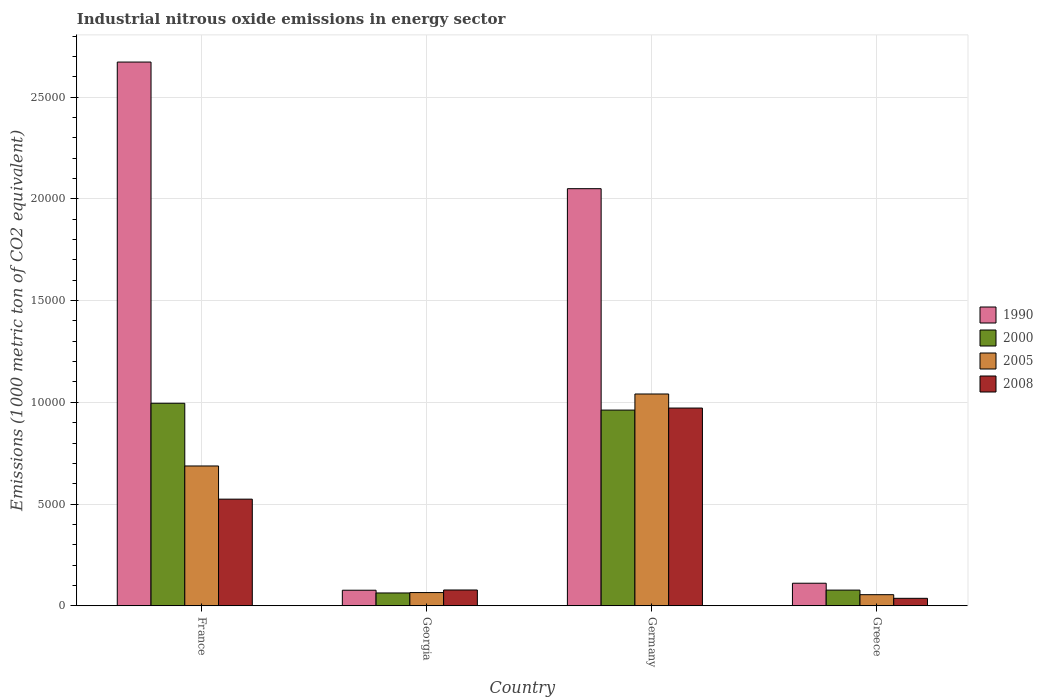How many different coloured bars are there?
Your answer should be compact. 4. Are the number of bars per tick equal to the number of legend labels?
Offer a very short reply. Yes. How many bars are there on the 1st tick from the left?
Make the answer very short. 4. How many bars are there on the 4th tick from the right?
Your answer should be very brief. 4. What is the amount of industrial nitrous oxide emitted in 1990 in France?
Your answer should be very brief. 2.67e+04. Across all countries, what is the maximum amount of industrial nitrous oxide emitted in 2005?
Your answer should be compact. 1.04e+04. Across all countries, what is the minimum amount of industrial nitrous oxide emitted in 2008?
Provide a short and direct response. 367.4. In which country was the amount of industrial nitrous oxide emitted in 2008 minimum?
Your response must be concise. Greece. What is the total amount of industrial nitrous oxide emitted in 2008 in the graph?
Offer a very short reply. 1.61e+04. What is the difference between the amount of industrial nitrous oxide emitted in 2008 in France and that in Georgia?
Provide a short and direct response. 4464.8. What is the difference between the amount of industrial nitrous oxide emitted in 1990 in Greece and the amount of industrial nitrous oxide emitted in 2005 in Georgia?
Give a very brief answer. 459. What is the average amount of industrial nitrous oxide emitted in 2005 per country?
Your answer should be very brief. 4619.1. What is the difference between the amount of industrial nitrous oxide emitted of/in 2000 and amount of industrial nitrous oxide emitted of/in 1990 in France?
Provide a short and direct response. -1.68e+04. What is the ratio of the amount of industrial nitrous oxide emitted in 2005 in France to that in Georgia?
Your response must be concise. 10.57. Is the amount of industrial nitrous oxide emitted in 2005 in Germany less than that in Greece?
Offer a very short reply. No. What is the difference between the highest and the second highest amount of industrial nitrous oxide emitted in 2000?
Offer a very short reply. 335.9. What is the difference between the highest and the lowest amount of industrial nitrous oxide emitted in 2005?
Ensure brevity in your answer.  9863.1. In how many countries, is the amount of industrial nitrous oxide emitted in 1990 greater than the average amount of industrial nitrous oxide emitted in 1990 taken over all countries?
Provide a short and direct response. 2. Is it the case that in every country, the sum of the amount of industrial nitrous oxide emitted in 2000 and amount of industrial nitrous oxide emitted in 2008 is greater than the sum of amount of industrial nitrous oxide emitted in 2005 and amount of industrial nitrous oxide emitted in 1990?
Your response must be concise. No. What does the 1st bar from the left in France represents?
Provide a succinct answer. 1990. What does the 1st bar from the right in Greece represents?
Your response must be concise. 2008. What is the difference between two consecutive major ticks on the Y-axis?
Offer a terse response. 5000. Are the values on the major ticks of Y-axis written in scientific E-notation?
Offer a terse response. No. Where does the legend appear in the graph?
Your answer should be compact. Center right. How many legend labels are there?
Make the answer very short. 4. How are the legend labels stacked?
Provide a short and direct response. Vertical. What is the title of the graph?
Offer a terse response. Industrial nitrous oxide emissions in energy sector. What is the label or title of the X-axis?
Ensure brevity in your answer.  Country. What is the label or title of the Y-axis?
Your response must be concise. Emissions (1000 metric ton of CO2 equivalent). What is the Emissions (1000 metric ton of CO2 equivalent) in 1990 in France?
Ensure brevity in your answer.  2.67e+04. What is the Emissions (1000 metric ton of CO2 equivalent) of 2000 in France?
Keep it short and to the point. 9953.8. What is the Emissions (1000 metric ton of CO2 equivalent) of 2005 in France?
Provide a short and direct response. 6871.6. What is the Emissions (1000 metric ton of CO2 equivalent) in 2008 in France?
Your answer should be very brief. 5241.3. What is the Emissions (1000 metric ton of CO2 equivalent) in 1990 in Georgia?
Your answer should be very brief. 765.3. What is the Emissions (1000 metric ton of CO2 equivalent) in 2000 in Georgia?
Ensure brevity in your answer.  630.5. What is the Emissions (1000 metric ton of CO2 equivalent) in 2005 in Georgia?
Your answer should be very brief. 650.1. What is the Emissions (1000 metric ton of CO2 equivalent) of 2008 in Georgia?
Make the answer very short. 776.5. What is the Emissions (1000 metric ton of CO2 equivalent) in 1990 in Germany?
Your answer should be compact. 2.05e+04. What is the Emissions (1000 metric ton of CO2 equivalent) of 2000 in Germany?
Keep it short and to the point. 9617.9. What is the Emissions (1000 metric ton of CO2 equivalent) in 2005 in Germany?
Provide a short and direct response. 1.04e+04. What is the Emissions (1000 metric ton of CO2 equivalent) in 2008 in Germany?
Your response must be concise. 9718.4. What is the Emissions (1000 metric ton of CO2 equivalent) in 1990 in Greece?
Your answer should be compact. 1109.1. What is the Emissions (1000 metric ton of CO2 equivalent) in 2000 in Greece?
Keep it short and to the point. 771. What is the Emissions (1000 metric ton of CO2 equivalent) in 2005 in Greece?
Make the answer very short. 545.8. What is the Emissions (1000 metric ton of CO2 equivalent) of 2008 in Greece?
Your answer should be very brief. 367.4. Across all countries, what is the maximum Emissions (1000 metric ton of CO2 equivalent) of 1990?
Ensure brevity in your answer.  2.67e+04. Across all countries, what is the maximum Emissions (1000 metric ton of CO2 equivalent) in 2000?
Give a very brief answer. 9953.8. Across all countries, what is the maximum Emissions (1000 metric ton of CO2 equivalent) of 2005?
Give a very brief answer. 1.04e+04. Across all countries, what is the maximum Emissions (1000 metric ton of CO2 equivalent) of 2008?
Your answer should be very brief. 9718.4. Across all countries, what is the minimum Emissions (1000 metric ton of CO2 equivalent) in 1990?
Provide a succinct answer. 765.3. Across all countries, what is the minimum Emissions (1000 metric ton of CO2 equivalent) in 2000?
Your response must be concise. 630.5. Across all countries, what is the minimum Emissions (1000 metric ton of CO2 equivalent) in 2005?
Keep it short and to the point. 545.8. Across all countries, what is the minimum Emissions (1000 metric ton of CO2 equivalent) in 2008?
Ensure brevity in your answer.  367.4. What is the total Emissions (1000 metric ton of CO2 equivalent) of 1990 in the graph?
Make the answer very short. 4.91e+04. What is the total Emissions (1000 metric ton of CO2 equivalent) of 2000 in the graph?
Give a very brief answer. 2.10e+04. What is the total Emissions (1000 metric ton of CO2 equivalent) in 2005 in the graph?
Provide a succinct answer. 1.85e+04. What is the total Emissions (1000 metric ton of CO2 equivalent) of 2008 in the graph?
Ensure brevity in your answer.  1.61e+04. What is the difference between the Emissions (1000 metric ton of CO2 equivalent) in 1990 in France and that in Georgia?
Offer a terse response. 2.60e+04. What is the difference between the Emissions (1000 metric ton of CO2 equivalent) in 2000 in France and that in Georgia?
Your answer should be compact. 9323.3. What is the difference between the Emissions (1000 metric ton of CO2 equivalent) in 2005 in France and that in Georgia?
Your answer should be compact. 6221.5. What is the difference between the Emissions (1000 metric ton of CO2 equivalent) in 2008 in France and that in Georgia?
Provide a succinct answer. 4464.8. What is the difference between the Emissions (1000 metric ton of CO2 equivalent) in 1990 in France and that in Germany?
Provide a short and direct response. 6222.7. What is the difference between the Emissions (1000 metric ton of CO2 equivalent) in 2000 in France and that in Germany?
Provide a short and direct response. 335.9. What is the difference between the Emissions (1000 metric ton of CO2 equivalent) of 2005 in France and that in Germany?
Give a very brief answer. -3537.3. What is the difference between the Emissions (1000 metric ton of CO2 equivalent) of 2008 in France and that in Germany?
Make the answer very short. -4477.1. What is the difference between the Emissions (1000 metric ton of CO2 equivalent) of 1990 in France and that in Greece?
Keep it short and to the point. 2.56e+04. What is the difference between the Emissions (1000 metric ton of CO2 equivalent) of 2000 in France and that in Greece?
Offer a terse response. 9182.8. What is the difference between the Emissions (1000 metric ton of CO2 equivalent) of 2005 in France and that in Greece?
Your answer should be very brief. 6325.8. What is the difference between the Emissions (1000 metric ton of CO2 equivalent) in 2008 in France and that in Greece?
Ensure brevity in your answer.  4873.9. What is the difference between the Emissions (1000 metric ton of CO2 equivalent) in 1990 in Georgia and that in Germany?
Offer a terse response. -1.97e+04. What is the difference between the Emissions (1000 metric ton of CO2 equivalent) in 2000 in Georgia and that in Germany?
Make the answer very short. -8987.4. What is the difference between the Emissions (1000 metric ton of CO2 equivalent) in 2005 in Georgia and that in Germany?
Your answer should be very brief. -9758.8. What is the difference between the Emissions (1000 metric ton of CO2 equivalent) of 2008 in Georgia and that in Germany?
Your answer should be very brief. -8941.9. What is the difference between the Emissions (1000 metric ton of CO2 equivalent) in 1990 in Georgia and that in Greece?
Provide a succinct answer. -343.8. What is the difference between the Emissions (1000 metric ton of CO2 equivalent) of 2000 in Georgia and that in Greece?
Keep it short and to the point. -140.5. What is the difference between the Emissions (1000 metric ton of CO2 equivalent) in 2005 in Georgia and that in Greece?
Provide a succinct answer. 104.3. What is the difference between the Emissions (1000 metric ton of CO2 equivalent) in 2008 in Georgia and that in Greece?
Provide a succinct answer. 409.1. What is the difference between the Emissions (1000 metric ton of CO2 equivalent) of 1990 in Germany and that in Greece?
Offer a very short reply. 1.94e+04. What is the difference between the Emissions (1000 metric ton of CO2 equivalent) of 2000 in Germany and that in Greece?
Provide a short and direct response. 8846.9. What is the difference between the Emissions (1000 metric ton of CO2 equivalent) in 2005 in Germany and that in Greece?
Ensure brevity in your answer.  9863.1. What is the difference between the Emissions (1000 metric ton of CO2 equivalent) in 2008 in Germany and that in Greece?
Keep it short and to the point. 9351. What is the difference between the Emissions (1000 metric ton of CO2 equivalent) in 1990 in France and the Emissions (1000 metric ton of CO2 equivalent) in 2000 in Georgia?
Your answer should be compact. 2.61e+04. What is the difference between the Emissions (1000 metric ton of CO2 equivalent) of 1990 in France and the Emissions (1000 metric ton of CO2 equivalent) of 2005 in Georgia?
Keep it short and to the point. 2.61e+04. What is the difference between the Emissions (1000 metric ton of CO2 equivalent) of 1990 in France and the Emissions (1000 metric ton of CO2 equivalent) of 2008 in Georgia?
Your answer should be compact. 2.59e+04. What is the difference between the Emissions (1000 metric ton of CO2 equivalent) in 2000 in France and the Emissions (1000 metric ton of CO2 equivalent) in 2005 in Georgia?
Offer a terse response. 9303.7. What is the difference between the Emissions (1000 metric ton of CO2 equivalent) of 2000 in France and the Emissions (1000 metric ton of CO2 equivalent) of 2008 in Georgia?
Offer a terse response. 9177.3. What is the difference between the Emissions (1000 metric ton of CO2 equivalent) of 2005 in France and the Emissions (1000 metric ton of CO2 equivalent) of 2008 in Georgia?
Ensure brevity in your answer.  6095.1. What is the difference between the Emissions (1000 metric ton of CO2 equivalent) of 1990 in France and the Emissions (1000 metric ton of CO2 equivalent) of 2000 in Germany?
Ensure brevity in your answer.  1.71e+04. What is the difference between the Emissions (1000 metric ton of CO2 equivalent) in 1990 in France and the Emissions (1000 metric ton of CO2 equivalent) in 2005 in Germany?
Offer a very short reply. 1.63e+04. What is the difference between the Emissions (1000 metric ton of CO2 equivalent) in 1990 in France and the Emissions (1000 metric ton of CO2 equivalent) in 2008 in Germany?
Keep it short and to the point. 1.70e+04. What is the difference between the Emissions (1000 metric ton of CO2 equivalent) in 2000 in France and the Emissions (1000 metric ton of CO2 equivalent) in 2005 in Germany?
Make the answer very short. -455.1. What is the difference between the Emissions (1000 metric ton of CO2 equivalent) of 2000 in France and the Emissions (1000 metric ton of CO2 equivalent) of 2008 in Germany?
Keep it short and to the point. 235.4. What is the difference between the Emissions (1000 metric ton of CO2 equivalent) in 2005 in France and the Emissions (1000 metric ton of CO2 equivalent) in 2008 in Germany?
Your response must be concise. -2846.8. What is the difference between the Emissions (1000 metric ton of CO2 equivalent) of 1990 in France and the Emissions (1000 metric ton of CO2 equivalent) of 2000 in Greece?
Your answer should be very brief. 2.60e+04. What is the difference between the Emissions (1000 metric ton of CO2 equivalent) of 1990 in France and the Emissions (1000 metric ton of CO2 equivalent) of 2005 in Greece?
Keep it short and to the point. 2.62e+04. What is the difference between the Emissions (1000 metric ton of CO2 equivalent) in 1990 in France and the Emissions (1000 metric ton of CO2 equivalent) in 2008 in Greece?
Make the answer very short. 2.64e+04. What is the difference between the Emissions (1000 metric ton of CO2 equivalent) of 2000 in France and the Emissions (1000 metric ton of CO2 equivalent) of 2005 in Greece?
Your response must be concise. 9408. What is the difference between the Emissions (1000 metric ton of CO2 equivalent) of 2000 in France and the Emissions (1000 metric ton of CO2 equivalent) of 2008 in Greece?
Offer a terse response. 9586.4. What is the difference between the Emissions (1000 metric ton of CO2 equivalent) in 2005 in France and the Emissions (1000 metric ton of CO2 equivalent) in 2008 in Greece?
Offer a very short reply. 6504.2. What is the difference between the Emissions (1000 metric ton of CO2 equivalent) in 1990 in Georgia and the Emissions (1000 metric ton of CO2 equivalent) in 2000 in Germany?
Your answer should be very brief. -8852.6. What is the difference between the Emissions (1000 metric ton of CO2 equivalent) of 1990 in Georgia and the Emissions (1000 metric ton of CO2 equivalent) of 2005 in Germany?
Give a very brief answer. -9643.6. What is the difference between the Emissions (1000 metric ton of CO2 equivalent) of 1990 in Georgia and the Emissions (1000 metric ton of CO2 equivalent) of 2008 in Germany?
Keep it short and to the point. -8953.1. What is the difference between the Emissions (1000 metric ton of CO2 equivalent) in 2000 in Georgia and the Emissions (1000 metric ton of CO2 equivalent) in 2005 in Germany?
Offer a terse response. -9778.4. What is the difference between the Emissions (1000 metric ton of CO2 equivalent) of 2000 in Georgia and the Emissions (1000 metric ton of CO2 equivalent) of 2008 in Germany?
Your answer should be compact. -9087.9. What is the difference between the Emissions (1000 metric ton of CO2 equivalent) in 2005 in Georgia and the Emissions (1000 metric ton of CO2 equivalent) in 2008 in Germany?
Provide a succinct answer. -9068.3. What is the difference between the Emissions (1000 metric ton of CO2 equivalent) of 1990 in Georgia and the Emissions (1000 metric ton of CO2 equivalent) of 2000 in Greece?
Keep it short and to the point. -5.7. What is the difference between the Emissions (1000 metric ton of CO2 equivalent) in 1990 in Georgia and the Emissions (1000 metric ton of CO2 equivalent) in 2005 in Greece?
Offer a very short reply. 219.5. What is the difference between the Emissions (1000 metric ton of CO2 equivalent) in 1990 in Georgia and the Emissions (1000 metric ton of CO2 equivalent) in 2008 in Greece?
Provide a short and direct response. 397.9. What is the difference between the Emissions (1000 metric ton of CO2 equivalent) in 2000 in Georgia and the Emissions (1000 metric ton of CO2 equivalent) in 2005 in Greece?
Offer a very short reply. 84.7. What is the difference between the Emissions (1000 metric ton of CO2 equivalent) in 2000 in Georgia and the Emissions (1000 metric ton of CO2 equivalent) in 2008 in Greece?
Your response must be concise. 263.1. What is the difference between the Emissions (1000 metric ton of CO2 equivalent) in 2005 in Georgia and the Emissions (1000 metric ton of CO2 equivalent) in 2008 in Greece?
Keep it short and to the point. 282.7. What is the difference between the Emissions (1000 metric ton of CO2 equivalent) of 1990 in Germany and the Emissions (1000 metric ton of CO2 equivalent) of 2000 in Greece?
Your answer should be compact. 1.97e+04. What is the difference between the Emissions (1000 metric ton of CO2 equivalent) of 1990 in Germany and the Emissions (1000 metric ton of CO2 equivalent) of 2005 in Greece?
Provide a succinct answer. 2.00e+04. What is the difference between the Emissions (1000 metric ton of CO2 equivalent) of 1990 in Germany and the Emissions (1000 metric ton of CO2 equivalent) of 2008 in Greece?
Provide a succinct answer. 2.01e+04. What is the difference between the Emissions (1000 metric ton of CO2 equivalent) in 2000 in Germany and the Emissions (1000 metric ton of CO2 equivalent) in 2005 in Greece?
Your response must be concise. 9072.1. What is the difference between the Emissions (1000 metric ton of CO2 equivalent) of 2000 in Germany and the Emissions (1000 metric ton of CO2 equivalent) of 2008 in Greece?
Provide a short and direct response. 9250.5. What is the difference between the Emissions (1000 metric ton of CO2 equivalent) of 2005 in Germany and the Emissions (1000 metric ton of CO2 equivalent) of 2008 in Greece?
Make the answer very short. 1.00e+04. What is the average Emissions (1000 metric ton of CO2 equivalent) in 1990 per country?
Give a very brief answer. 1.23e+04. What is the average Emissions (1000 metric ton of CO2 equivalent) of 2000 per country?
Offer a very short reply. 5243.3. What is the average Emissions (1000 metric ton of CO2 equivalent) of 2005 per country?
Keep it short and to the point. 4619.1. What is the average Emissions (1000 metric ton of CO2 equivalent) in 2008 per country?
Your answer should be compact. 4025.9. What is the difference between the Emissions (1000 metric ton of CO2 equivalent) in 1990 and Emissions (1000 metric ton of CO2 equivalent) in 2000 in France?
Your response must be concise. 1.68e+04. What is the difference between the Emissions (1000 metric ton of CO2 equivalent) in 1990 and Emissions (1000 metric ton of CO2 equivalent) in 2005 in France?
Provide a short and direct response. 1.99e+04. What is the difference between the Emissions (1000 metric ton of CO2 equivalent) in 1990 and Emissions (1000 metric ton of CO2 equivalent) in 2008 in France?
Provide a succinct answer. 2.15e+04. What is the difference between the Emissions (1000 metric ton of CO2 equivalent) of 2000 and Emissions (1000 metric ton of CO2 equivalent) of 2005 in France?
Offer a very short reply. 3082.2. What is the difference between the Emissions (1000 metric ton of CO2 equivalent) of 2000 and Emissions (1000 metric ton of CO2 equivalent) of 2008 in France?
Your answer should be compact. 4712.5. What is the difference between the Emissions (1000 metric ton of CO2 equivalent) in 2005 and Emissions (1000 metric ton of CO2 equivalent) in 2008 in France?
Keep it short and to the point. 1630.3. What is the difference between the Emissions (1000 metric ton of CO2 equivalent) of 1990 and Emissions (1000 metric ton of CO2 equivalent) of 2000 in Georgia?
Offer a very short reply. 134.8. What is the difference between the Emissions (1000 metric ton of CO2 equivalent) in 1990 and Emissions (1000 metric ton of CO2 equivalent) in 2005 in Georgia?
Make the answer very short. 115.2. What is the difference between the Emissions (1000 metric ton of CO2 equivalent) of 1990 and Emissions (1000 metric ton of CO2 equivalent) of 2008 in Georgia?
Provide a succinct answer. -11.2. What is the difference between the Emissions (1000 metric ton of CO2 equivalent) in 2000 and Emissions (1000 metric ton of CO2 equivalent) in 2005 in Georgia?
Keep it short and to the point. -19.6. What is the difference between the Emissions (1000 metric ton of CO2 equivalent) of 2000 and Emissions (1000 metric ton of CO2 equivalent) of 2008 in Georgia?
Ensure brevity in your answer.  -146. What is the difference between the Emissions (1000 metric ton of CO2 equivalent) of 2005 and Emissions (1000 metric ton of CO2 equivalent) of 2008 in Georgia?
Provide a succinct answer. -126.4. What is the difference between the Emissions (1000 metric ton of CO2 equivalent) of 1990 and Emissions (1000 metric ton of CO2 equivalent) of 2000 in Germany?
Make the answer very short. 1.09e+04. What is the difference between the Emissions (1000 metric ton of CO2 equivalent) of 1990 and Emissions (1000 metric ton of CO2 equivalent) of 2005 in Germany?
Ensure brevity in your answer.  1.01e+04. What is the difference between the Emissions (1000 metric ton of CO2 equivalent) in 1990 and Emissions (1000 metric ton of CO2 equivalent) in 2008 in Germany?
Offer a very short reply. 1.08e+04. What is the difference between the Emissions (1000 metric ton of CO2 equivalent) in 2000 and Emissions (1000 metric ton of CO2 equivalent) in 2005 in Germany?
Your answer should be very brief. -791. What is the difference between the Emissions (1000 metric ton of CO2 equivalent) of 2000 and Emissions (1000 metric ton of CO2 equivalent) of 2008 in Germany?
Offer a terse response. -100.5. What is the difference between the Emissions (1000 metric ton of CO2 equivalent) in 2005 and Emissions (1000 metric ton of CO2 equivalent) in 2008 in Germany?
Offer a terse response. 690.5. What is the difference between the Emissions (1000 metric ton of CO2 equivalent) of 1990 and Emissions (1000 metric ton of CO2 equivalent) of 2000 in Greece?
Your answer should be very brief. 338.1. What is the difference between the Emissions (1000 metric ton of CO2 equivalent) of 1990 and Emissions (1000 metric ton of CO2 equivalent) of 2005 in Greece?
Your answer should be compact. 563.3. What is the difference between the Emissions (1000 metric ton of CO2 equivalent) in 1990 and Emissions (1000 metric ton of CO2 equivalent) in 2008 in Greece?
Your answer should be very brief. 741.7. What is the difference between the Emissions (1000 metric ton of CO2 equivalent) in 2000 and Emissions (1000 metric ton of CO2 equivalent) in 2005 in Greece?
Your answer should be very brief. 225.2. What is the difference between the Emissions (1000 metric ton of CO2 equivalent) of 2000 and Emissions (1000 metric ton of CO2 equivalent) of 2008 in Greece?
Make the answer very short. 403.6. What is the difference between the Emissions (1000 metric ton of CO2 equivalent) of 2005 and Emissions (1000 metric ton of CO2 equivalent) of 2008 in Greece?
Your answer should be compact. 178.4. What is the ratio of the Emissions (1000 metric ton of CO2 equivalent) of 1990 in France to that in Georgia?
Offer a very short reply. 34.92. What is the ratio of the Emissions (1000 metric ton of CO2 equivalent) in 2000 in France to that in Georgia?
Make the answer very short. 15.79. What is the ratio of the Emissions (1000 metric ton of CO2 equivalent) in 2005 in France to that in Georgia?
Provide a short and direct response. 10.57. What is the ratio of the Emissions (1000 metric ton of CO2 equivalent) of 2008 in France to that in Georgia?
Your response must be concise. 6.75. What is the ratio of the Emissions (1000 metric ton of CO2 equivalent) in 1990 in France to that in Germany?
Your response must be concise. 1.3. What is the ratio of the Emissions (1000 metric ton of CO2 equivalent) of 2000 in France to that in Germany?
Ensure brevity in your answer.  1.03. What is the ratio of the Emissions (1000 metric ton of CO2 equivalent) in 2005 in France to that in Germany?
Provide a short and direct response. 0.66. What is the ratio of the Emissions (1000 metric ton of CO2 equivalent) of 2008 in France to that in Germany?
Give a very brief answer. 0.54. What is the ratio of the Emissions (1000 metric ton of CO2 equivalent) in 1990 in France to that in Greece?
Your answer should be compact. 24.09. What is the ratio of the Emissions (1000 metric ton of CO2 equivalent) in 2000 in France to that in Greece?
Your answer should be compact. 12.91. What is the ratio of the Emissions (1000 metric ton of CO2 equivalent) of 2005 in France to that in Greece?
Provide a succinct answer. 12.59. What is the ratio of the Emissions (1000 metric ton of CO2 equivalent) in 2008 in France to that in Greece?
Offer a very short reply. 14.27. What is the ratio of the Emissions (1000 metric ton of CO2 equivalent) of 1990 in Georgia to that in Germany?
Give a very brief answer. 0.04. What is the ratio of the Emissions (1000 metric ton of CO2 equivalent) of 2000 in Georgia to that in Germany?
Offer a very short reply. 0.07. What is the ratio of the Emissions (1000 metric ton of CO2 equivalent) in 2005 in Georgia to that in Germany?
Your answer should be compact. 0.06. What is the ratio of the Emissions (1000 metric ton of CO2 equivalent) of 2008 in Georgia to that in Germany?
Ensure brevity in your answer.  0.08. What is the ratio of the Emissions (1000 metric ton of CO2 equivalent) in 1990 in Georgia to that in Greece?
Ensure brevity in your answer.  0.69. What is the ratio of the Emissions (1000 metric ton of CO2 equivalent) in 2000 in Georgia to that in Greece?
Provide a succinct answer. 0.82. What is the ratio of the Emissions (1000 metric ton of CO2 equivalent) of 2005 in Georgia to that in Greece?
Give a very brief answer. 1.19. What is the ratio of the Emissions (1000 metric ton of CO2 equivalent) of 2008 in Georgia to that in Greece?
Offer a terse response. 2.11. What is the ratio of the Emissions (1000 metric ton of CO2 equivalent) in 1990 in Germany to that in Greece?
Provide a succinct answer. 18.48. What is the ratio of the Emissions (1000 metric ton of CO2 equivalent) of 2000 in Germany to that in Greece?
Provide a succinct answer. 12.47. What is the ratio of the Emissions (1000 metric ton of CO2 equivalent) in 2005 in Germany to that in Greece?
Keep it short and to the point. 19.07. What is the ratio of the Emissions (1000 metric ton of CO2 equivalent) of 2008 in Germany to that in Greece?
Your answer should be compact. 26.45. What is the difference between the highest and the second highest Emissions (1000 metric ton of CO2 equivalent) in 1990?
Offer a very short reply. 6222.7. What is the difference between the highest and the second highest Emissions (1000 metric ton of CO2 equivalent) in 2000?
Make the answer very short. 335.9. What is the difference between the highest and the second highest Emissions (1000 metric ton of CO2 equivalent) in 2005?
Make the answer very short. 3537.3. What is the difference between the highest and the second highest Emissions (1000 metric ton of CO2 equivalent) in 2008?
Provide a short and direct response. 4477.1. What is the difference between the highest and the lowest Emissions (1000 metric ton of CO2 equivalent) in 1990?
Your answer should be very brief. 2.60e+04. What is the difference between the highest and the lowest Emissions (1000 metric ton of CO2 equivalent) of 2000?
Ensure brevity in your answer.  9323.3. What is the difference between the highest and the lowest Emissions (1000 metric ton of CO2 equivalent) of 2005?
Ensure brevity in your answer.  9863.1. What is the difference between the highest and the lowest Emissions (1000 metric ton of CO2 equivalent) in 2008?
Give a very brief answer. 9351. 